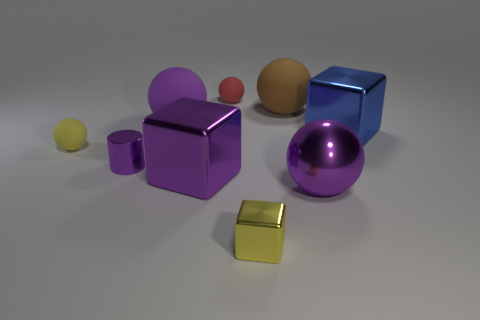Subtract all large blue blocks. How many blocks are left? 2 Add 1 yellow blocks. How many objects exist? 10 Subtract all brown cubes. Subtract all red cylinders. How many cubes are left? 3 Add 3 tiny red balls. How many tiny red balls exist? 4 Subtract all purple blocks. How many blocks are left? 2 Subtract 1 blue blocks. How many objects are left? 8 Subtract all blocks. How many objects are left? 6 Subtract 5 spheres. How many spheres are left? 0 Subtract all green spheres. How many green blocks are left? 0 Subtract all purple metallic cylinders. Subtract all blue things. How many objects are left? 7 